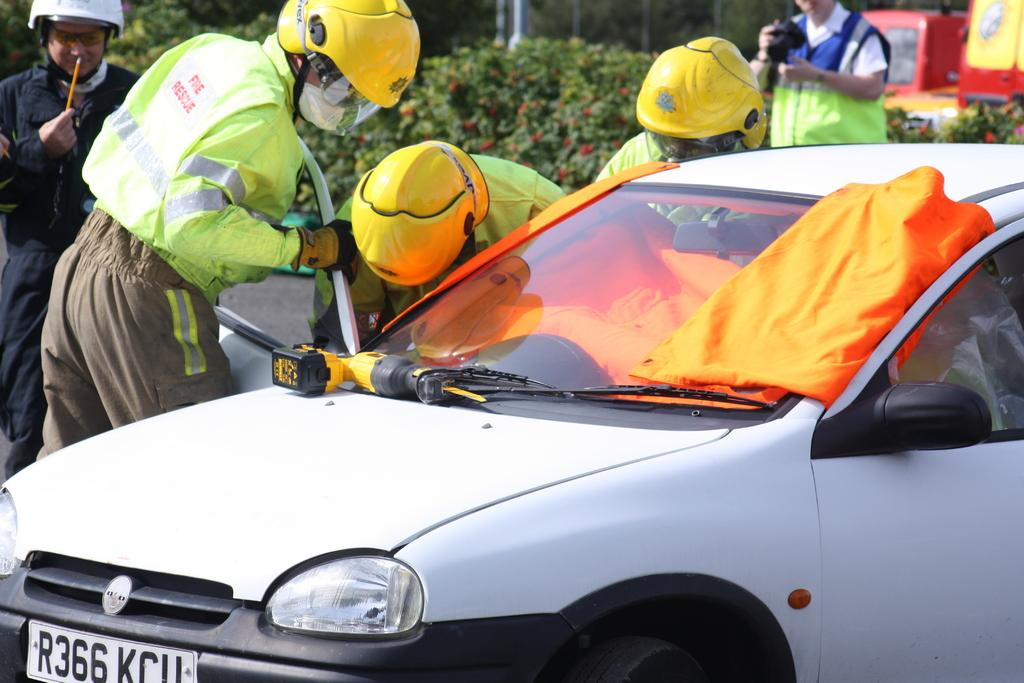How many people are in the image? There is a group of people in the image, but the exact number is not specified. What are the people in the image doing? The group of people is standing in the image. What type of vehicle is present in the image? There is a vehicle in the image, and it is white in color. What can be seen in the background of the image? There are plants in the background of the image, and they are green in color. What type of beam is holding up the underwear in the image? There is no beam or underwear present in the image. How many sticks are visible in the image? There are no sticks visible in the image. 